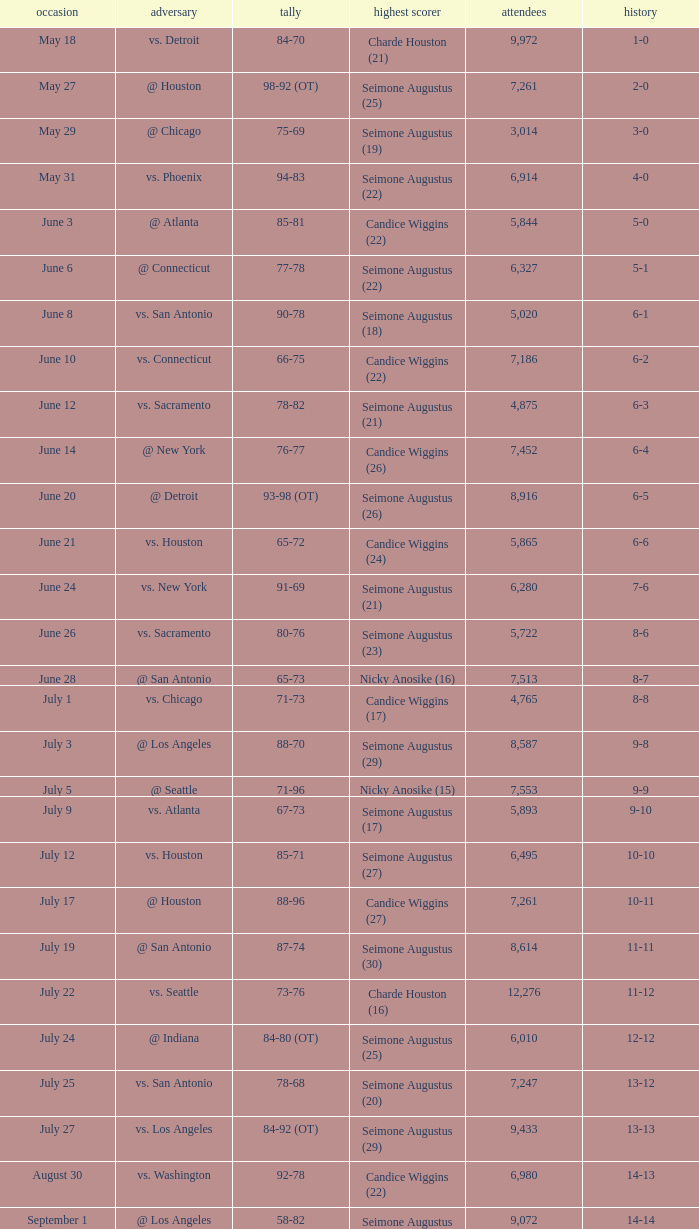Which Attendance has a Date of september 7? 7999.0. I'm looking to parse the entire table for insights. Could you assist me with that? {'header': ['occasion', 'adversary', 'tally', 'highest scorer', 'attendees', 'history'], 'rows': [['May 18', 'vs. Detroit', '84-70', 'Charde Houston (21)', '9,972', '1-0'], ['May 27', '@ Houston', '98-92 (OT)', 'Seimone Augustus (25)', '7,261', '2-0'], ['May 29', '@ Chicago', '75-69', 'Seimone Augustus (19)', '3,014', '3-0'], ['May 31', 'vs. Phoenix', '94-83', 'Seimone Augustus (22)', '6,914', '4-0'], ['June 3', '@ Atlanta', '85-81', 'Candice Wiggins (22)', '5,844', '5-0'], ['June 6', '@ Connecticut', '77-78', 'Seimone Augustus (22)', '6,327', '5-1'], ['June 8', 'vs. San Antonio', '90-78', 'Seimone Augustus (18)', '5,020', '6-1'], ['June 10', 'vs. Connecticut', '66-75', 'Candice Wiggins (22)', '7,186', '6-2'], ['June 12', 'vs. Sacramento', '78-82', 'Seimone Augustus (21)', '4,875', '6-3'], ['June 14', '@ New York', '76-77', 'Candice Wiggins (26)', '7,452', '6-4'], ['June 20', '@ Detroit', '93-98 (OT)', 'Seimone Augustus (26)', '8,916', '6-5'], ['June 21', 'vs. Houston', '65-72', 'Candice Wiggins (24)', '5,865', '6-6'], ['June 24', 'vs. New York', '91-69', 'Seimone Augustus (21)', '6,280', '7-6'], ['June 26', 'vs. Sacramento', '80-76', 'Seimone Augustus (23)', '5,722', '8-6'], ['June 28', '@ San Antonio', '65-73', 'Nicky Anosike (16)', '7,513', '8-7'], ['July 1', 'vs. Chicago', '71-73', 'Candice Wiggins (17)', '4,765', '8-8'], ['July 3', '@ Los Angeles', '88-70', 'Seimone Augustus (29)', '8,587', '9-8'], ['July 5', '@ Seattle', '71-96', 'Nicky Anosike (15)', '7,553', '9-9'], ['July 9', 'vs. Atlanta', '67-73', 'Seimone Augustus (17)', '5,893', '9-10'], ['July 12', 'vs. Houston', '85-71', 'Seimone Augustus (27)', '6,495', '10-10'], ['July 17', '@ Houston', '88-96', 'Candice Wiggins (27)', '7,261', '10-11'], ['July 19', '@ San Antonio', '87-74', 'Seimone Augustus (30)', '8,614', '11-11'], ['July 22', 'vs. Seattle', '73-76', 'Charde Houston (16)', '12,276', '11-12'], ['July 24', '@ Indiana', '84-80 (OT)', 'Seimone Augustus (25)', '6,010', '12-12'], ['July 25', 'vs. San Antonio', '78-68', 'Seimone Augustus (20)', '7,247', '13-12'], ['July 27', 'vs. Los Angeles', '84-92 (OT)', 'Seimone Augustus (29)', '9,433', '13-13'], ['August 30', 'vs. Washington', '92-78', 'Candice Wiggins (22)', '6,980', '14-13'], ['September 1', '@ Los Angeles', '58-82', 'Seimone Augustus (13)', '9,072', '14-14'], ['September 3', '@ Phoenix', '96-103', 'Seimone Augustus (27)', '7,722', '14-15'], ['September 6', '@ Seattle', '88-96', 'Seimone Augustus (26)', '9,339', '14-16'], ['September 7', '@ Sacramento', '71-78', 'Charde Houston (19)', '7,999', '14-17'], ['September 9', 'vs. Indiana', '86-76', 'Charde Houston (18)', '6,706', '15-17'], ['September 12', 'vs. Phoenix', '87-96', 'Lindsey Harding (20)', '8,343', '15-18'], ['September 14', '@ Washington', '96-70', 'Charde Houston (18)', '10,438', '16-18']]} 